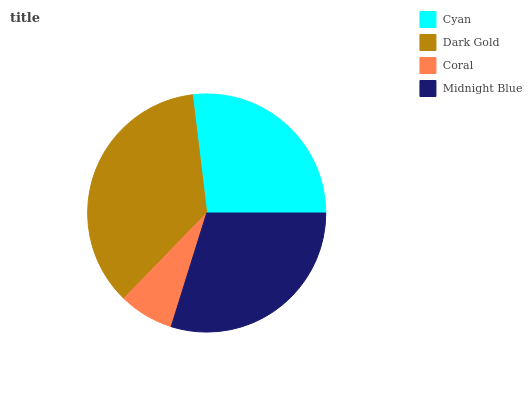Is Coral the minimum?
Answer yes or no. Yes. Is Dark Gold the maximum?
Answer yes or no. Yes. Is Dark Gold the minimum?
Answer yes or no. No. Is Coral the maximum?
Answer yes or no. No. Is Dark Gold greater than Coral?
Answer yes or no. Yes. Is Coral less than Dark Gold?
Answer yes or no. Yes. Is Coral greater than Dark Gold?
Answer yes or no. No. Is Dark Gold less than Coral?
Answer yes or no. No. Is Midnight Blue the high median?
Answer yes or no. Yes. Is Cyan the low median?
Answer yes or no. Yes. Is Coral the high median?
Answer yes or no. No. Is Midnight Blue the low median?
Answer yes or no. No. 